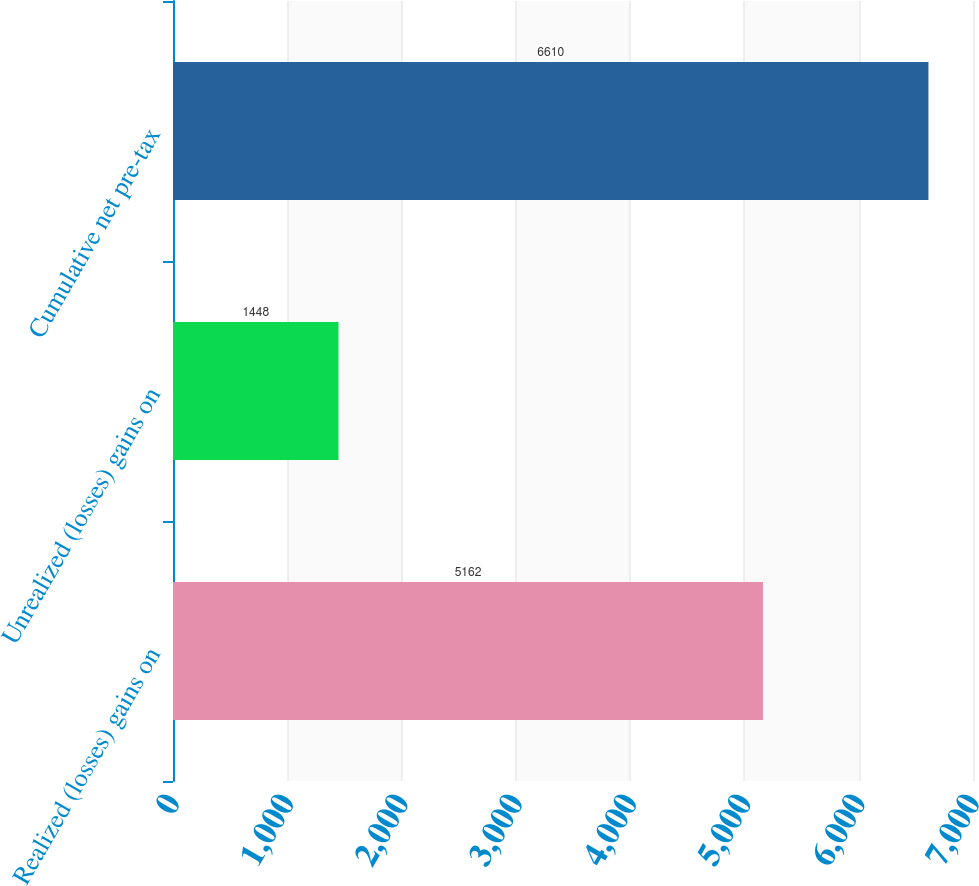Convert chart to OTSL. <chart><loc_0><loc_0><loc_500><loc_500><bar_chart><fcel>Realized (losses) gains on<fcel>Unrealized (losses) gains on<fcel>Cumulative net pre-tax<nl><fcel>5162<fcel>1448<fcel>6610<nl></chart> 